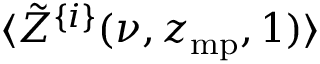<formula> <loc_0><loc_0><loc_500><loc_500>\langle \tilde { Z } ^ { \{ i \} } ( \nu , z _ { m p } , 1 ) \rangle</formula> 